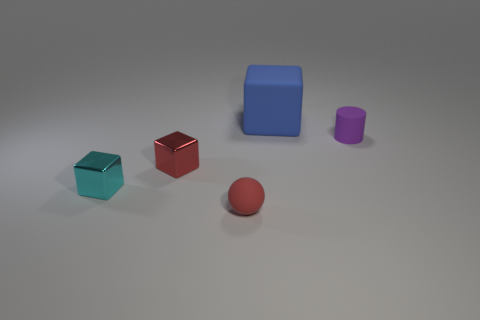Add 1 green metallic cylinders. How many objects exist? 6 Subtract all balls. How many objects are left? 4 Add 4 red metal blocks. How many red metal blocks exist? 5 Subtract 1 cyan cubes. How many objects are left? 4 Subtract all tiny rubber cylinders. Subtract all tiny metallic objects. How many objects are left? 2 Add 5 red rubber spheres. How many red rubber spheres are left? 6 